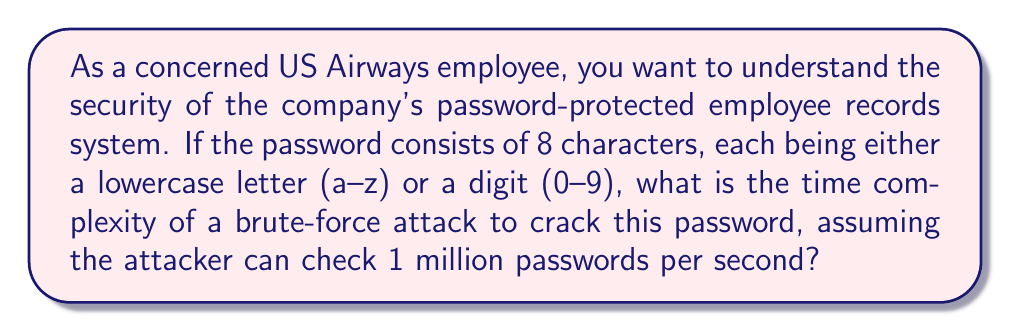Teach me how to tackle this problem. To solve this problem, let's follow these steps:

1) First, we need to calculate the total number of possible passwords:
   - There are 26 lowercase letters and 10 digits, so 36 possible characters for each position.
   - The password is 8 characters long.
   - Total number of possible passwords = $36^8$

2) The time complexity of a brute-force attack is directly proportional to the number of possible passwords. In Big O notation, this is $O(36^8)$.

3) To find the actual time it would take:
   - Number of passwords = $36^8 = 2,821,109,907,456$
   - Rate of checking = 1,000,000 passwords per second
   - Time taken = $\frac{2,821,109,907,456}{1,000,000} = 2,821,109.907456$ seconds

4) Convert to more readable units:
   $2,821,109.907456 \text{ seconds} = 32.65 \text{ days}$

This calculation shows why even seemingly simple passwords can be relatively secure against brute-force attacks, highlighting the importance of strong password policies in protecting sensitive employee data.
Answer: $O(36^8)$ 